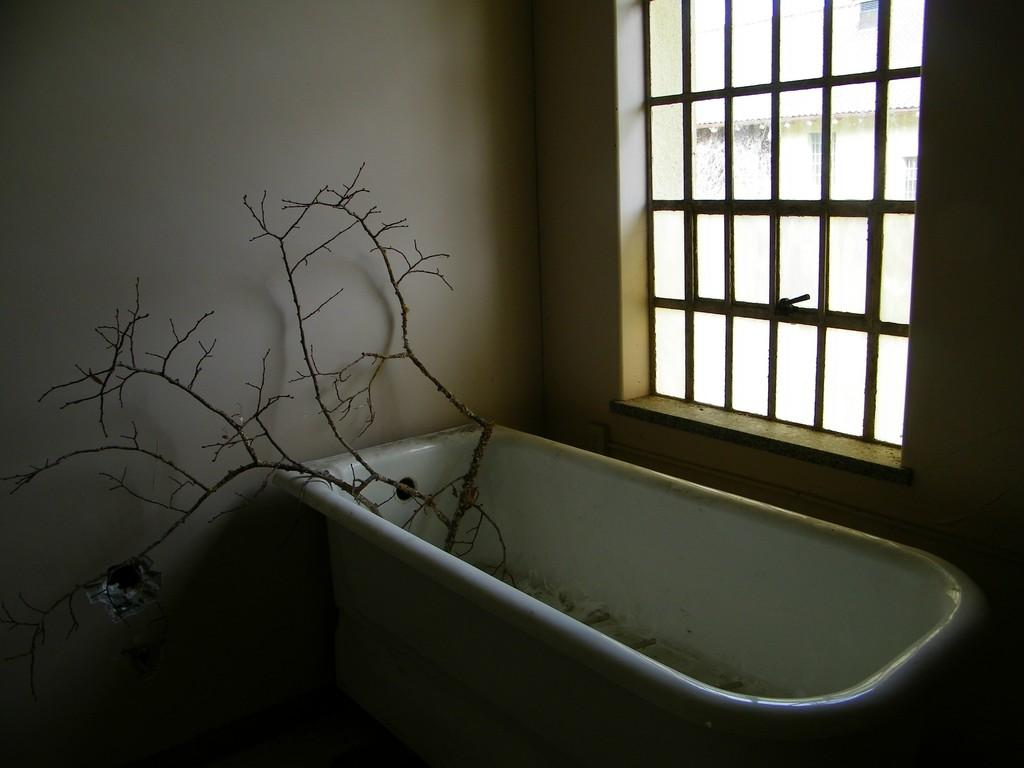What is the main object in the image? There is a bath tub in the image. What can be seen on the right side of the image? There is a glass window on the right side of the image. What is inside the bath tub? There are dried branches in the bath tub. Where is the map located in the image? There is no map present in the image. What type of cover is placed on the table in the image? There is no table or cover present in the image. 